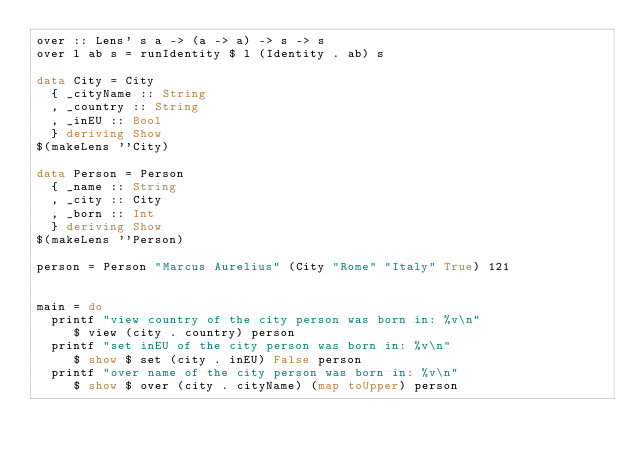Convert code to text. <code><loc_0><loc_0><loc_500><loc_500><_Haskell_>over :: Lens' s a -> (a -> a) -> s -> s
over l ab s = runIdentity $ l (Identity . ab) s 

data City = City
  { _cityName :: String
  , _country :: String
  , _inEU :: Bool
  } deriving Show
$(makeLens ''City)

data Person = Person 
  { _name :: String
  , _city :: City
  , _born :: Int
  } deriving Show
$(makeLens ''Person)

person = Person "Marcus Aurelius" (City "Rome" "Italy" True) 121


main = do
  printf "view country of the city person was born in: %v\n"
     $ view (city . country) person
  printf "set inEU of the city person was born in: %v\n"
     $ show $ set (city . inEU) False person
  printf "over name of the city person was born in: %v\n"
     $ show $ over (city . cityName) (map toUpper) person
</code> 